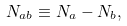<formula> <loc_0><loc_0><loc_500><loc_500>N _ { a b } \equiv N _ { a } - N _ { b } ,</formula> 